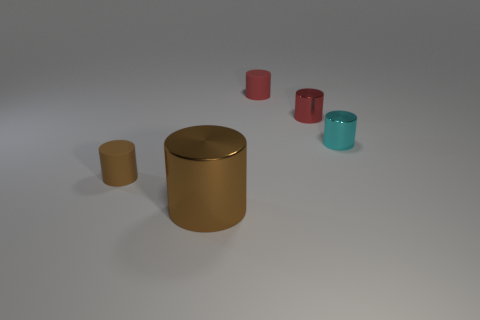Are there any brown shiny cylinders behind the tiny brown matte cylinder?
Your response must be concise. No. What is the color of the large cylinder?
Offer a terse response. Brown. There is a large metal thing; does it have the same color as the small rubber thing in front of the tiny red rubber object?
Your answer should be compact. Yes. Are there any objects that have the same size as the cyan cylinder?
Your response must be concise. Yes. The rubber cylinder that is the same color as the large object is what size?
Your answer should be very brief. Small. What material is the thing that is left of the big brown thing?
Your answer should be compact. Rubber. Are there the same number of rubber objects that are to the right of the red shiny object and cylinders that are behind the cyan thing?
Your response must be concise. No. Is the size of the metal thing that is to the left of the tiny red matte cylinder the same as the matte thing that is in front of the small cyan metal cylinder?
Make the answer very short. No. What number of big cylinders are the same color as the large thing?
Provide a succinct answer. 0. There is a cylinder that is the same color as the big thing; what material is it?
Give a very brief answer. Rubber. 